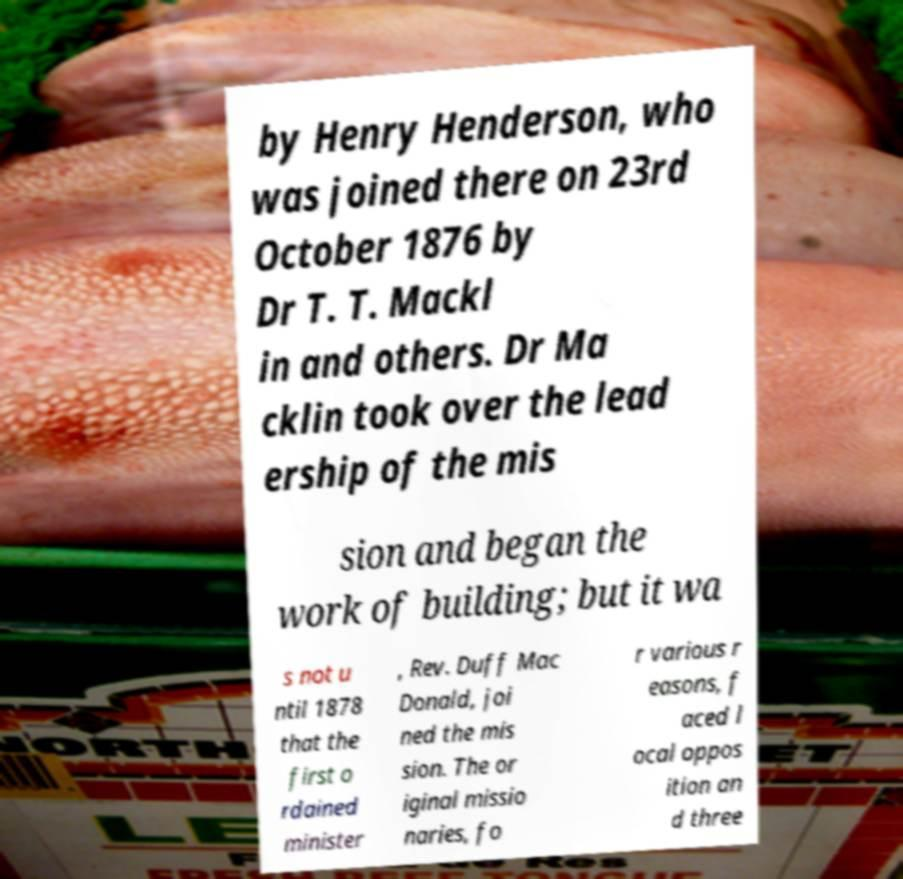Can you accurately transcribe the text from the provided image for me? by Henry Henderson, who was joined there on 23rd October 1876 by Dr T. T. Mackl in and others. Dr Ma cklin took over the lead ership of the mis sion and began the work of building; but it wa s not u ntil 1878 that the first o rdained minister , Rev. Duff Mac Donald, joi ned the mis sion. The or iginal missio naries, fo r various r easons, f aced l ocal oppos ition an d three 